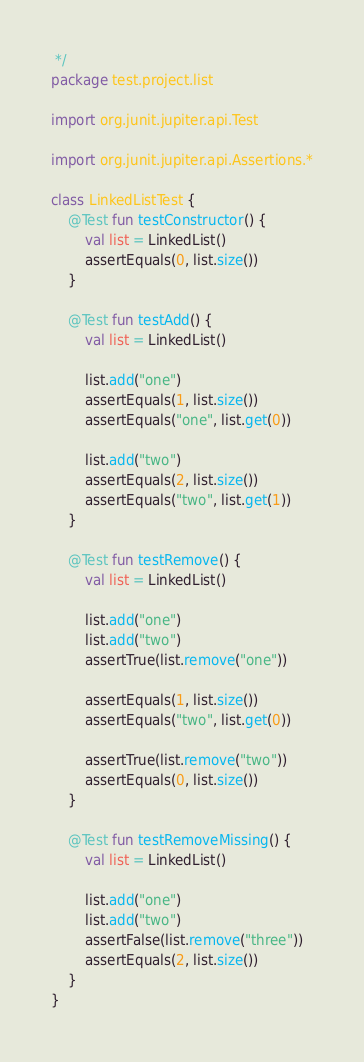<code> <loc_0><loc_0><loc_500><loc_500><_Kotlin_> */
package test.project.list

import org.junit.jupiter.api.Test

import org.junit.jupiter.api.Assertions.*

class LinkedListTest {
    @Test fun testConstructor() {
        val list = LinkedList()
        assertEquals(0, list.size())
    }

    @Test fun testAdd() {
        val list = LinkedList()

        list.add("one")
        assertEquals(1, list.size())
        assertEquals("one", list.get(0))

        list.add("two")
        assertEquals(2, list.size())
        assertEquals("two", list.get(1))
    }

    @Test fun testRemove() {
        val list = LinkedList()

        list.add("one")
        list.add("two")
        assertTrue(list.remove("one"))

        assertEquals(1, list.size())
        assertEquals("two", list.get(0))

        assertTrue(list.remove("two"))
        assertEquals(0, list.size())
    }

    @Test fun testRemoveMissing() {
        val list = LinkedList()

        list.add("one")
        list.add("two")
        assertFalse(list.remove("three"))
        assertEquals(2, list.size())
    }
}
</code> 